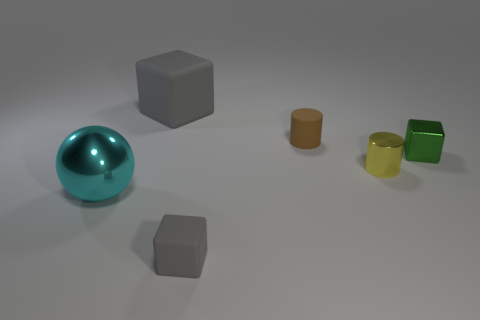Subtract all rubber cubes. How many cubes are left? 1 Subtract all gray blocks. How many blocks are left? 1 Add 2 tiny gray matte things. How many objects exist? 8 Subtract all spheres. How many objects are left? 5 Add 4 brown rubber cylinders. How many brown rubber cylinders exist? 5 Subtract 0 gray spheres. How many objects are left? 6 Subtract 1 blocks. How many blocks are left? 2 Subtract all cyan blocks. Subtract all yellow spheres. How many blocks are left? 3 Subtract all cyan spheres. How many green cubes are left? 1 Subtract all tiny gray metallic spheres. Subtract all matte cylinders. How many objects are left? 5 